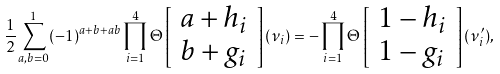Convert formula to latex. <formula><loc_0><loc_0><loc_500><loc_500>\frac { 1 } { 2 } \sum _ { a , b = 0 } ^ { 1 } ( - 1 ) ^ { a + b + a b } \prod _ { i = 1 } ^ { 4 } \Theta \left [ \begin{array} { l l } a + h _ { i } \\ b + g _ { i } \end{array} \right ] ( \nu _ { i } ) = - \prod _ { i = 1 } ^ { 4 } \Theta \left [ \begin{array} { l l } 1 - h _ { i } \\ 1 - g _ { i } \end{array} \right ] ( \nu ^ { \prime } _ { i } ) ,</formula> 